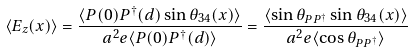<formula> <loc_0><loc_0><loc_500><loc_500>\langle E _ { z } ( x ) \rangle = \frac { \langle P ( 0 ) P ^ { \dagger } ( d ) \sin \theta _ { 3 4 } ( x ) \rangle } { a ^ { 2 } e \langle P ( 0 ) P ^ { \dagger } ( d ) \rangle } = \frac { \langle \sin \theta _ { P P ^ { \dagger } } \sin \theta _ { 3 4 } ( x ) \rangle } { a ^ { 2 } e \langle \cos \theta _ { P P ^ { \dagger } } \rangle }</formula> 